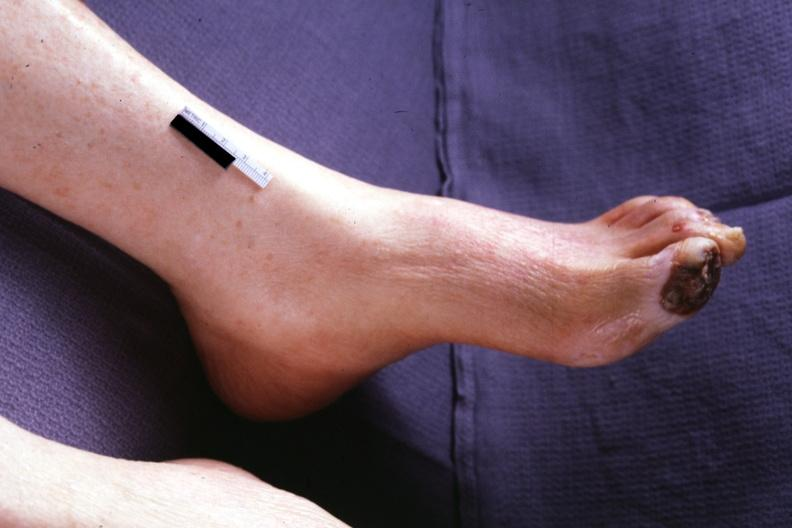s foot present?
Answer the question using a single word or phrase. Yes 